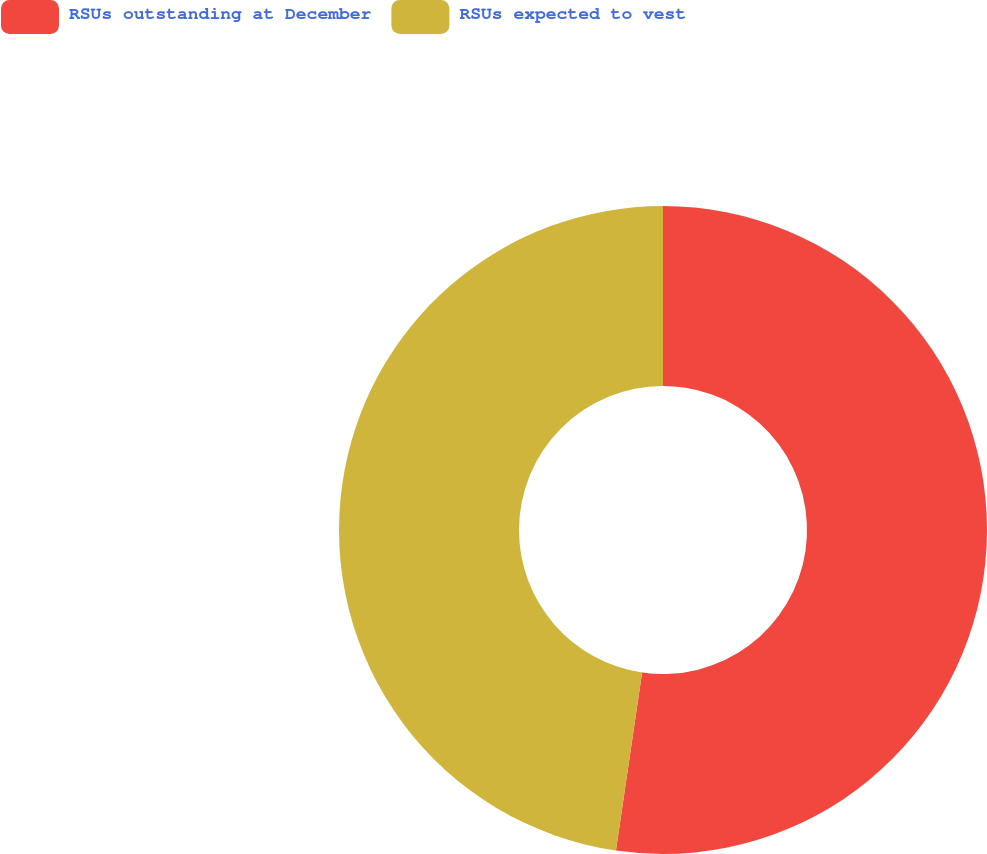Convert chart. <chart><loc_0><loc_0><loc_500><loc_500><pie_chart><fcel>RSUs outstanding at December<fcel>RSUs expected to vest<nl><fcel>52.32%<fcel>47.68%<nl></chart> 